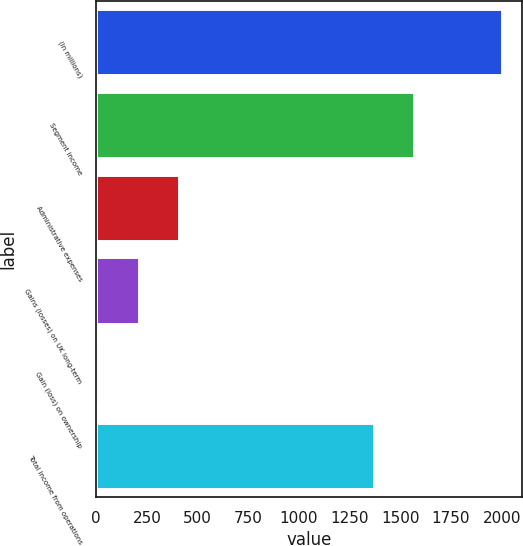Convert chart. <chart><loc_0><loc_0><loc_500><loc_500><bar_chart><fcel>(In millions)<fcel>Segment income<fcel>Administrative expenses<fcel>Gains (losses) on UK long-term<fcel>Gain (loss) on ownership<fcel>Total income from operations<nl><fcel>2002<fcel>1569<fcel>410<fcel>211<fcel>12<fcel>1370<nl></chart> 